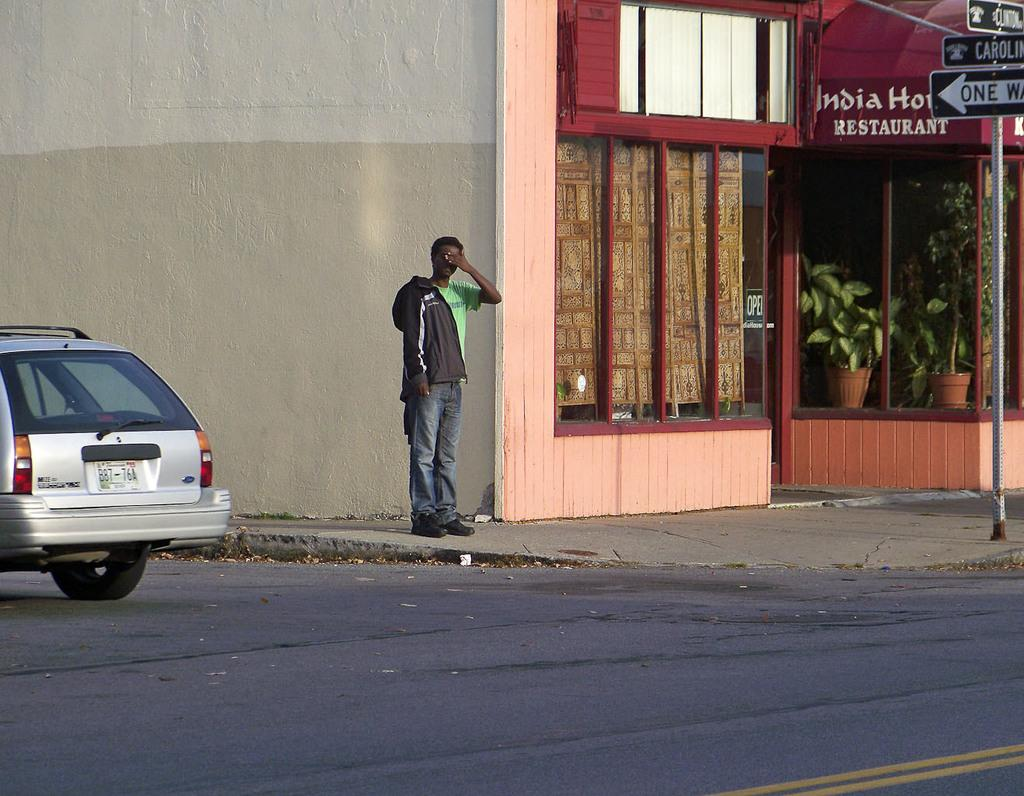What is the main subject in the image? There is a person in the image. What can be seen on the road in the image? There is a car on the road in the image. What type of structure is visible in the image? There is a building in the image. What type of window is present in the image? There is a glass window in the image. What type of decorative items can be seen in the image? There are flower pots in the image. What type of signage is visible in the image? There are boards in the image. What type of vertical structure is visible in the image? There is a pole in the image. What type of wall can be seen in the image? There is a white and cream color wall in the image. What type of snow can be seen falling in the image? There is no snow present in the image. What type of smell can be detected from the image? The image is visual, and therefore, no smell can be detected from it. 